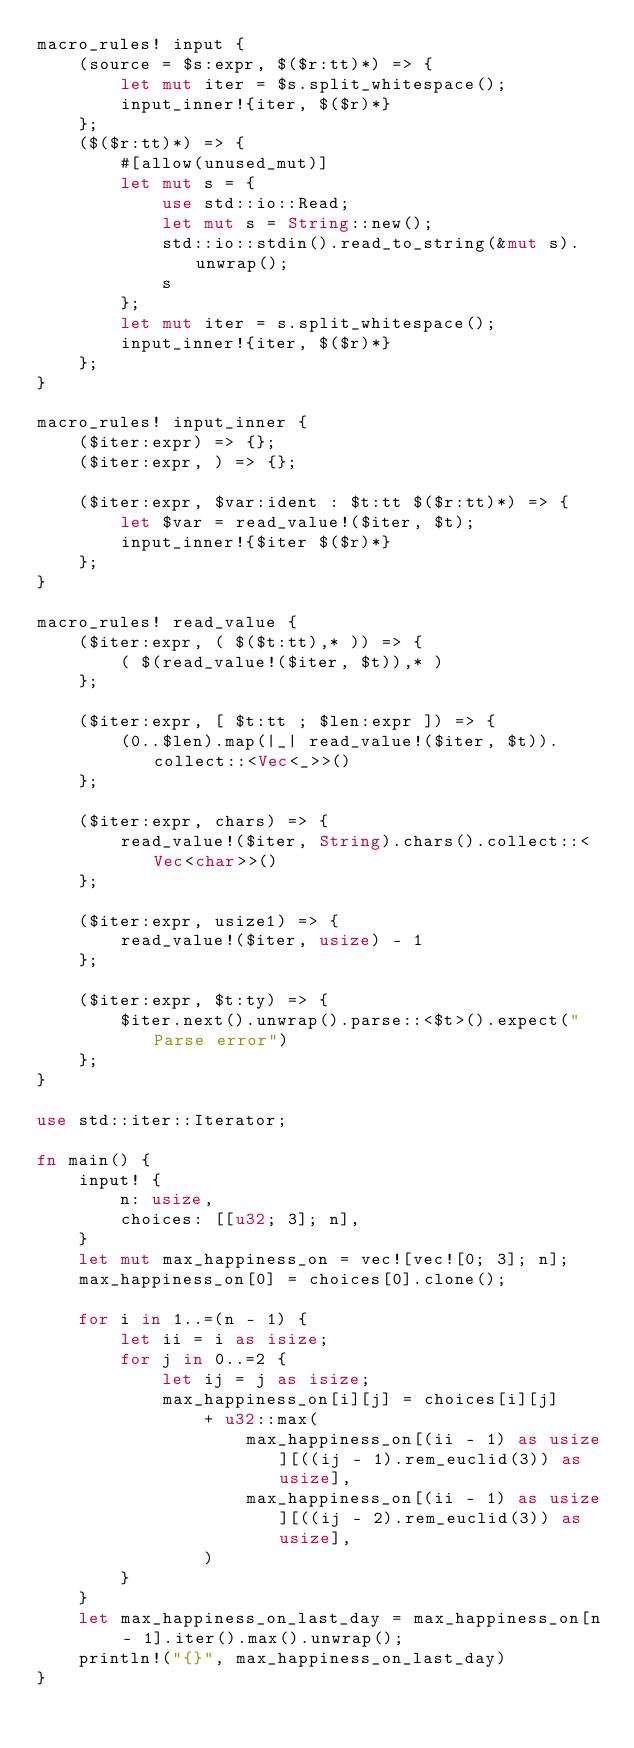<code> <loc_0><loc_0><loc_500><loc_500><_Rust_>macro_rules! input {
    (source = $s:expr, $($r:tt)*) => {
        let mut iter = $s.split_whitespace();
        input_inner!{iter, $($r)*}
    };
    ($($r:tt)*) => {
        #[allow(unused_mut)]
        let mut s = {
            use std::io::Read;
            let mut s = String::new();
            std::io::stdin().read_to_string(&mut s).unwrap();
            s
        };
        let mut iter = s.split_whitespace();
        input_inner!{iter, $($r)*}
    };
}

macro_rules! input_inner {
    ($iter:expr) => {};
    ($iter:expr, ) => {};

    ($iter:expr, $var:ident : $t:tt $($r:tt)*) => {
        let $var = read_value!($iter, $t);
        input_inner!{$iter $($r)*}
    };
}

macro_rules! read_value {
    ($iter:expr, ( $($t:tt),* )) => {
        ( $(read_value!($iter, $t)),* )
    };

    ($iter:expr, [ $t:tt ; $len:expr ]) => {
        (0..$len).map(|_| read_value!($iter, $t)).collect::<Vec<_>>()
    };

    ($iter:expr, chars) => {
        read_value!($iter, String).chars().collect::<Vec<char>>()
    };

    ($iter:expr, usize1) => {
        read_value!($iter, usize) - 1
    };

    ($iter:expr, $t:ty) => {
        $iter.next().unwrap().parse::<$t>().expect("Parse error")
    };
}

use std::iter::Iterator;

fn main() {
    input! {
        n: usize,
        choices: [[u32; 3]; n],
    }
    let mut max_happiness_on = vec![vec![0; 3]; n];
    max_happiness_on[0] = choices[0].clone();

    for i in 1..=(n - 1) {
        let ii = i as isize;
        for j in 0..=2 {
            let ij = j as isize;
            max_happiness_on[i][j] = choices[i][j]
                + u32::max(
                    max_happiness_on[(ii - 1) as usize][((ij - 1).rem_euclid(3)) as usize],
                    max_happiness_on[(ii - 1) as usize][((ij - 2).rem_euclid(3)) as usize],
                )
        }
    }
    let max_happiness_on_last_day = max_happiness_on[n - 1].iter().max().unwrap();
    println!("{}", max_happiness_on_last_day)
}
</code> 